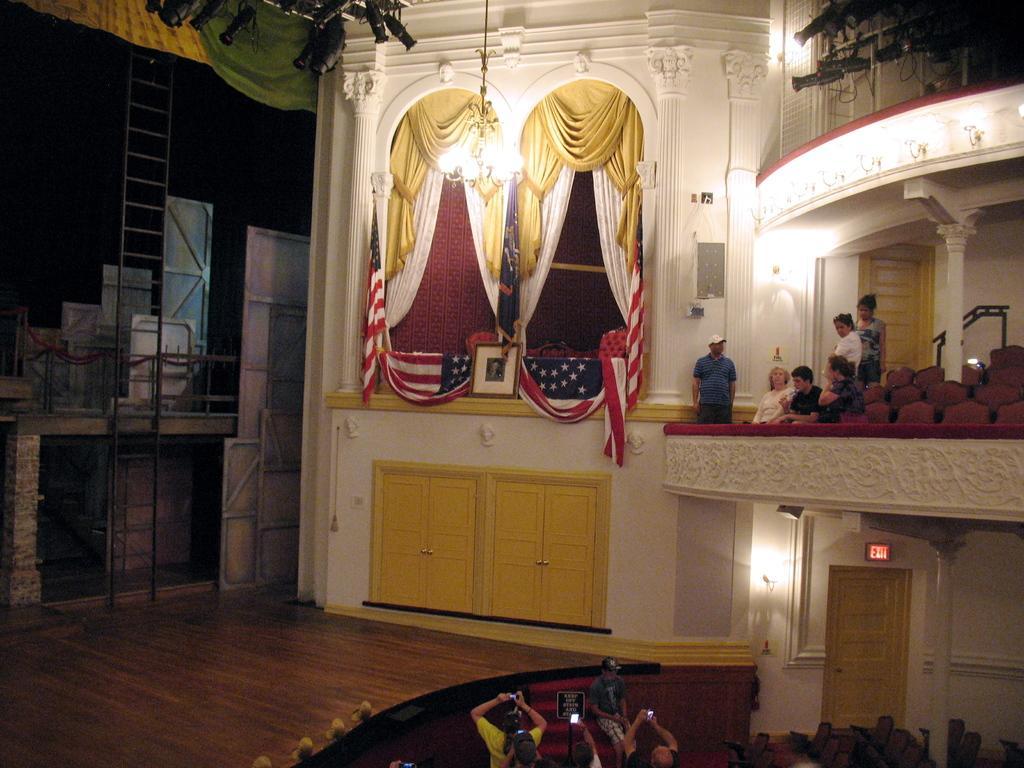Can you describe this image briefly? In this picture we can see some people sitting on chairs, some people are standing and some people holding objects. On the left side of the people there is a stage, board, curtains, flags, chandelier, ladder and some objects. At the top there are lights. 